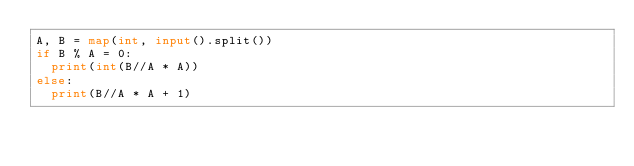Convert code to text. <code><loc_0><loc_0><loc_500><loc_500><_Python_>A, B = map(int, input().split())
if B % A = 0:
  print(int(B//A * A))
else:
  print(B//A * A + 1)</code> 